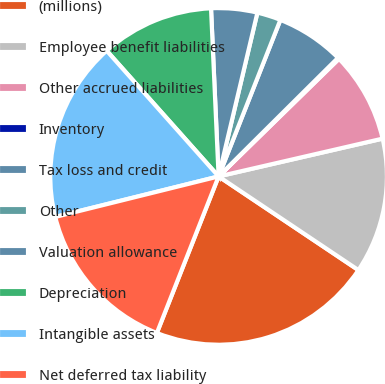Convert chart to OTSL. <chart><loc_0><loc_0><loc_500><loc_500><pie_chart><fcel>(millions)<fcel>Employee benefit liabilities<fcel>Other accrued liabilities<fcel>Inventory<fcel>Tax loss and credit<fcel>Other<fcel>Valuation allowance<fcel>Depreciation<fcel>Intangible assets<fcel>Net deferred tax liability<nl><fcel>21.58%<fcel>13.0%<fcel>8.71%<fcel>0.13%<fcel>6.57%<fcel>2.28%<fcel>4.42%<fcel>10.86%<fcel>17.29%<fcel>15.15%<nl></chart> 